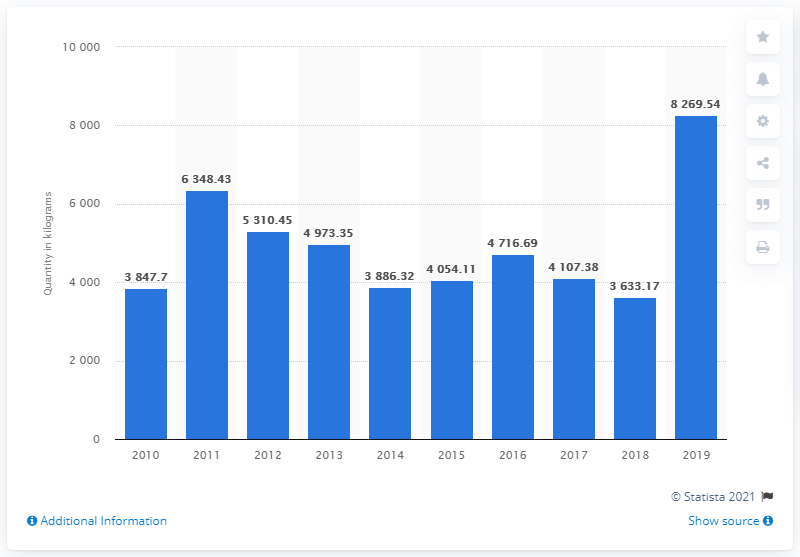Identify some key points in this picture. A total of 8,269.54 kilograms of cocaine was seized in Italy in 2019. 